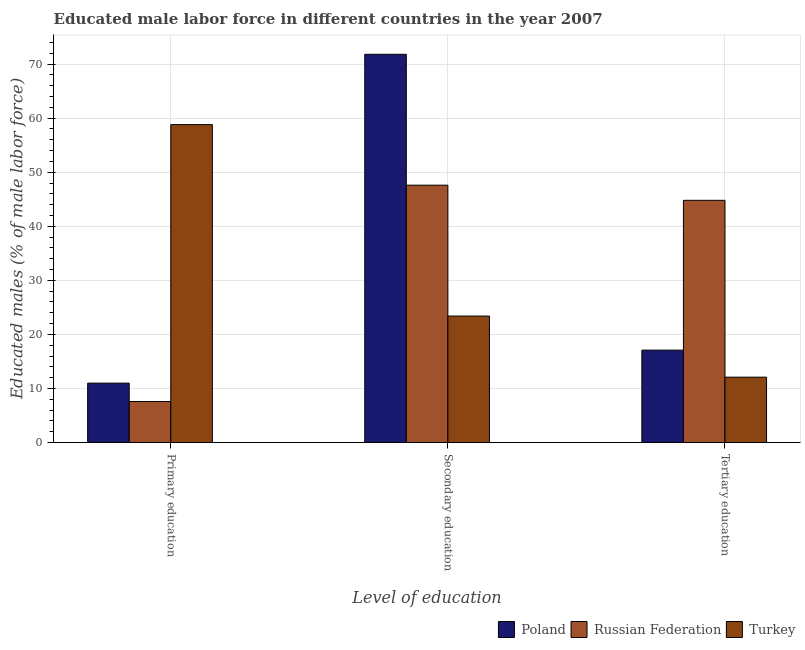How many groups of bars are there?
Provide a short and direct response. 3. How many bars are there on the 2nd tick from the right?
Your answer should be very brief. 3. What is the percentage of male labor force who received secondary education in Turkey?
Make the answer very short. 23.4. Across all countries, what is the maximum percentage of male labor force who received primary education?
Keep it short and to the point. 58.8. Across all countries, what is the minimum percentage of male labor force who received tertiary education?
Make the answer very short. 12.1. In which country was the percentage of male labor force who received primary education maximum?
Ensure brevity in your answer.  Turkey. What is the total percentage of male labor force who received secondary education in the graph?
Your answer should be compact. 142.8. What is the difference between the percentage of male labor force who received primary education in Russian Federation and that in Turkey?
Your response must be concise. -51.2. What is the difference between the percentage of male labor force who received tertiary education in Turkey and the percentage of male labor force who received primary education in Poland?
Provide a succinct answer. 1.1. What is the average percentage of male labor force who received primary education per country?
Your response must be concise. 25.8. What is the difference between the percentage of male labor force who received secondary education and percentage of male labor force who received primary education in Poland?
Offer a terse response. 60.8. In how many countries, is the percentage of male labor force who received primary education greater than 64 %?
Your answer should be very brief. 0. What is the ratio of the percentage of male labor force who received secondary education in Russian Federation to that in Turkey?
Keep it short and to the point. 2.03. What is the difference between the highest and the second highest percentage of male labor force who received primary education?
Your response must be concise. 47.8. What is the difference between the highest and the lowest percentage of male labor force who received secondary education?
Your response must be concise. 48.4. In how many countries, is the percentage of male labor force who received tertiary education greater than the average percentage of male labor force who received tertiary education taken over all countries?
Ensure brevity in your answer.  1. Is the sum of the percentage of male labor force who received tertiary education in Russian Federation and Turkey greater than the maximum percentage of male labor force who received primary education across all countries?
Give a very brief answer. No. What does the 3rd bar from the left in Primary education represents?
Make the answer very short. Turkey. What does the 3rd bar from the right in Primary education represents?
Make the answer very short. Poland. What is the difference between two consecutive major ticks on the Y-axis?
Give a very brief answer. 10. Does the graph contain any zero values?
Your response must be concise. No. How are the legend labels stacked?
Keep it short and to the point. Horizontal. What is the title of the graph?
Give a very brief answer. Educated male labor force in different countries in the year 2007. What is the label or title of the X-axis?
Your answer should be very brief. Level of education. What is the label or title of the Y-axis?
Provide a succinct answer. Educated males (% of male labor force). What is the Educated males (% of male labor force) in Poland in Primary education?
Your answer should be compact. 11. What is the Educated males (% of male labor force) of Russian Federation in Primary education?
Offer a very short reply. 7.6. What is the Educated males (% of male labor force) of Turkey in Primary education?
Your answer should be compact. 58.8. What is the Educated males (% of male labor force) of Poland in Secondary education?
Offer a terse response. 71.8. What is the Educated males (% of male labor force) of Russian Federation in Secondary education?
Your answer should be very brief. 47.6. What is the Educated males (% of male labor force) of Turkey in Secondary education?
Ensure brevity in your answer.  23.4. What is the Educated males (% of male labor force) of Poland in Tertiary education?
Your answer should be very brief. 17.1. What is the Educated males (% of male labor force) in Russian Federation in Tertiary education?
Provide a succinct answer. 44.8. What is the Educated males (% of male labor force) in Turkey in Tertiary education?
Your response must be concise. 12.1. Across all Level of education, what is the maximum Educated males (% of male labor force) of Poland?
Provide a succinct answer. 71.8. Across all Level of education, what is the maximum Educated males (% of male labor force) in Russian Federation?
Ensure brevity in your answer.  47.6. Across all Level of education, what is the maximum Educated males (% of male labor force) of Turkey?
Your answer should be very brief. 58.8. Across all Level of education, what is the minimum Educated males (% of male labor force) in Poland?
Your answer should be very brief. 11. Across all Level of education, what is the minimum Educated males (% of male labor force) of Russian Federation?
Provide a succinct answer. 7.6. Across all Level of education, what is the minimum Educated males (% of male labor force) in Turkey?
Provide a succinct answer. 12.1. What is the total Educated males (% of male labor force) in Poland in the graph?
Your answer should be compact. 99.9. What is the total Educated males (% of male labor force) of Turkey in the graph?
Keep it short and to the point. 94.3. What is the difference between the Educated males (% of male labor force) of Poland in Primary education and that in Secondary education?
Provide a succinct answer. -60.8. What is the difference between the Educated males (% of male labor force) of Turkey in Primary education and that in Secondary education?
Ensure brevity in your answer.  35.4. What is the difference between the Educated males (% of male labor force) of Poland in Primary education and that in Tertiary education?
Offer a terse response. -6.1. What is the difference between the Educated males (% of male labor force) in Russian Federation in Primary education and that in Tertiary education?
Your response must be concise. -37.2. What is the difference between the Educated males (% of male labor force) of Turkey in Primary education and that in Tertiary education?
Ensure brevity in your answer.  46.7. What is the difference between the Educated males (% of male labor force) in Poland in Secondary education and that in Tertiary education?
Keep it short and to the point. 54.7. What is the difference between the Educated males (% of male labor force) of Russian Federation in Secondary education and that in Tertiary education?
Give a very brief answer. 2.8. What is the difference between the Educated males (% of male labor force) of Turkey in Secondary education and that in Tertiary education?
Give a very brief answer. 11.3. What is the difference between the Educated males (% of male labor force) in Poland in Primary education and the Educated males (% of male labor force) in Russian Federation in Secondary education?
Provide a short and direct response. -36.6. What is the difference between the Educated males (% of male labor force) in Poland in Primary education and the Educated males (% of male labor force) in Turkey in Secondary education?
Your answer should be compact. -12.4. What is the difference between the Educated males (% of male labor force) of Russian Federation in Primary education and the Educated males (% of male labor force) of Turkey in Secondary education?
Provide a short and direct response. -15.8. What is the difference between the Educated males (% of male labor force) of Poland in Primary education and the Educated males (% of male labor force) of Russian Federation in Tertiary education?
Your answer should be compact. -33.8. What is the difference between the Educated males (% of male labor force) of Poland in Primary education and the Educated males (% of male labor force) of Turkey in Tertiary education?
Make the answer very short. -1.1. What is the difference between the Educated males (% of male labor force) in Russian Federation in Primary education and the Educated males (% of male labor force) in Turkey in Tertiary education?
Provide a succinct answer. -4.5. What is the difference between the Educated males (% of male labor force) in Poland in Secondary education and the Educated males (% of male labor force) in Turkey in Tertiary education?
Give a very brief answer. 59.7. What is the difference between the Educated males (% of male labor force) of Russian Federation in Secondary education and the Educated males (% of male labor force) of Turkey in Tertiary education?
Keep it short and to the point. 35.5. What is the average Educated males (% of male labor force) of Poland per Level of education?
Provide a succinct answer. 33.3. What is the average Educated males (% of male labor force) in Russian Federation per Level of education?
Keep it short and to the point. 33.33. What is the average Educated males (% of male labor force) of Turkey per Level of education?
Ensure brevity in your answer.  31.43. What is the difference between the Educated males (% of male labor force) of Poland and Educated males (% of male labor force) of Turkey in Primary education?
Keep it short and to the point. -47.8. What is the difference between the Educated males (% of male labor force) in Russian Federation and Educated males (% of male labor force) in Turkey in Primary education?
Your answer should be compact. -51.2. What is the difference between the Educated males (% of male labor force) of Poland and Educated males (% of male labor force) of Russian Federation in Secondary education?
Provide a short and direct response. 24.2. What is the difference between the Educated males (% of male labor force) in Poland and Educated males (% of male labor force) in Turkey in Secondary education?
Provide a short and direct response. 48.4. What is the difference between the Educated males (% of male labor force) of Russian Federation and Educated males (% of male labor force) of Turkey in Secondary education?
Offer a very short reply. 24.2. What is the difference between the Educated males (% of male labor force) in Poland and Educated males (% of male labor force) in Russian Federation in Tertiary education?
Your answer should be compact. -27.7. What is the difference between the Educated males (% of male labor force) of Russian Federation and Educated males (% of male labor force) of Turkey in Tertiary education?
Keep it short and to the point. 32.7. What is the ratio of the Educated males (% of male labor force) in Poland in Primary education to that in Secondary education?
Offer a terse response. 0.15. What is the ratio of the Educated males (% of male labor force) of Russian Federation in Primary education to that in Secondary education?
Provide a short and direct response. 0.16. What is the ratio of the Educated males (% of male labor force) of Turkey in Primary education to that in Secondary education?
Your answer should be compact. 2.51. What is the ratio of the Educated males (% of male labor force) in Poland in Primary education to that in Tertiary education?
Ensure brevity in your answer.  0.64. What is the ratio of the Educated males (% of male labor force) of Russian Federation in Primary education to that in Tertiary education?
Offer a very short reply. 0.17. What is the ratio of the Educated males (% of male labor force) in Turkey in Primary education to that in Tertiary education?
Your answer should be very brief. 4.86. What is the ratio of the Educated males (% of male labor force) of Poland in Secondary education to that in Tertiary education?
Offer a very short reply. 4.2. What is the ratio of the Educated males (% of male labor force) of Russian Federation in Secondary education to that in Tertiary education?
Keep it short and to the point. 1.06. What is the ratio of the Educated males (% of male labor force) of Turkey in Secondary education to that in Tertiary education?
Ensure brevity in your answer.  1.93. What is the difference between the highest and the second highest Educated males (% of male labor force) of Poland?
Your response must be concise. 54.7. What is the difference between the highest and the second highest Educated males (% of male labor force) of Russian Federation?
Offer a very short reply. 2.8. What is the difference between the highest and the second highest Educated males (% of male labor force) in Turkey?
Give a very brief answer. 35.4. What is the difference between the highest and the lowest Educated males (% of male labor force) of Poland?
Ensure brevity in your answer.  60.8. What is the difference between the highest and the lowest Educated males (% of male labor force) of Russian Federation?
Provide a short and direct response. 40. What is the difference between the highest and the lowest Educated males (% of male labor force) of Turkey?
Give a very brief answer. 46.7. 